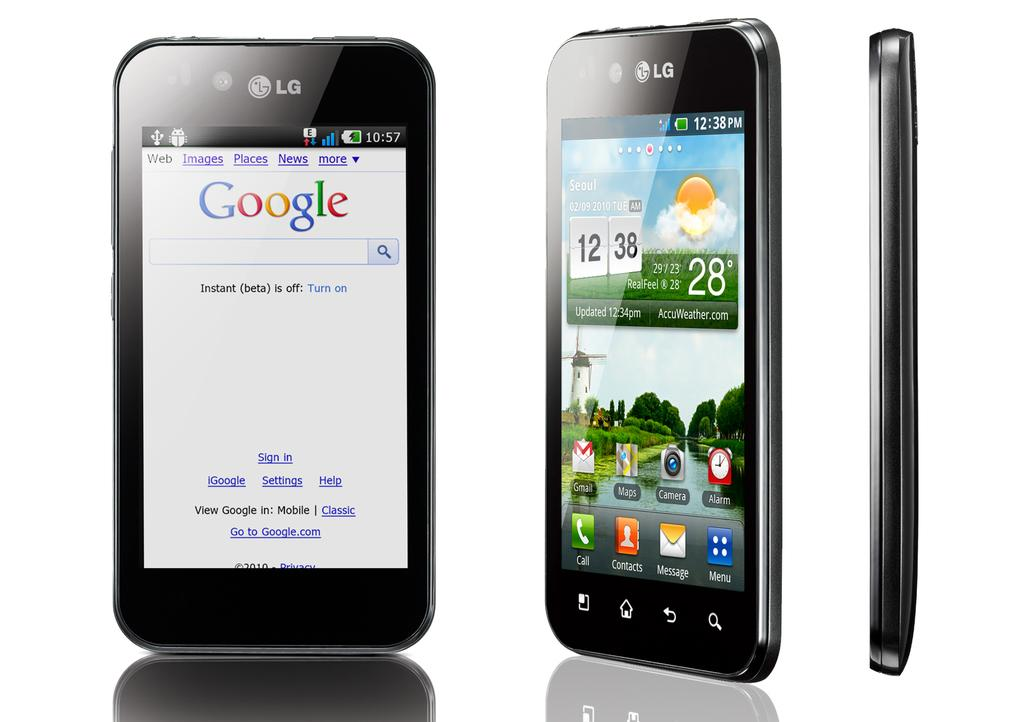<image>
Offer a succinct explanation of the picture presented. Google home page is displayed on the phone to the left. 